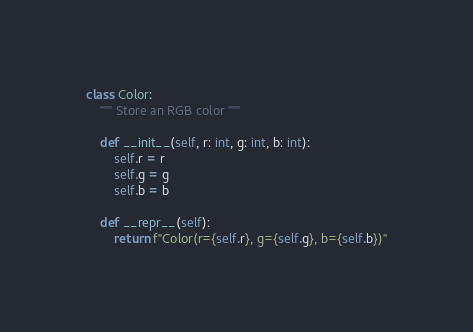Convert code to text. <code><loc_0><loc_0><loc_500><loc_500><_Python_>class Color:
    """ Store an RGB color """

    def __init__(self, r: int, g: int, b: int):
        self.r = r
        self.g = g
        self.b = b

    def __repr__(self):
        return f"Color(r={self.r}, g={self.g}, b={self.b})"
</code> 